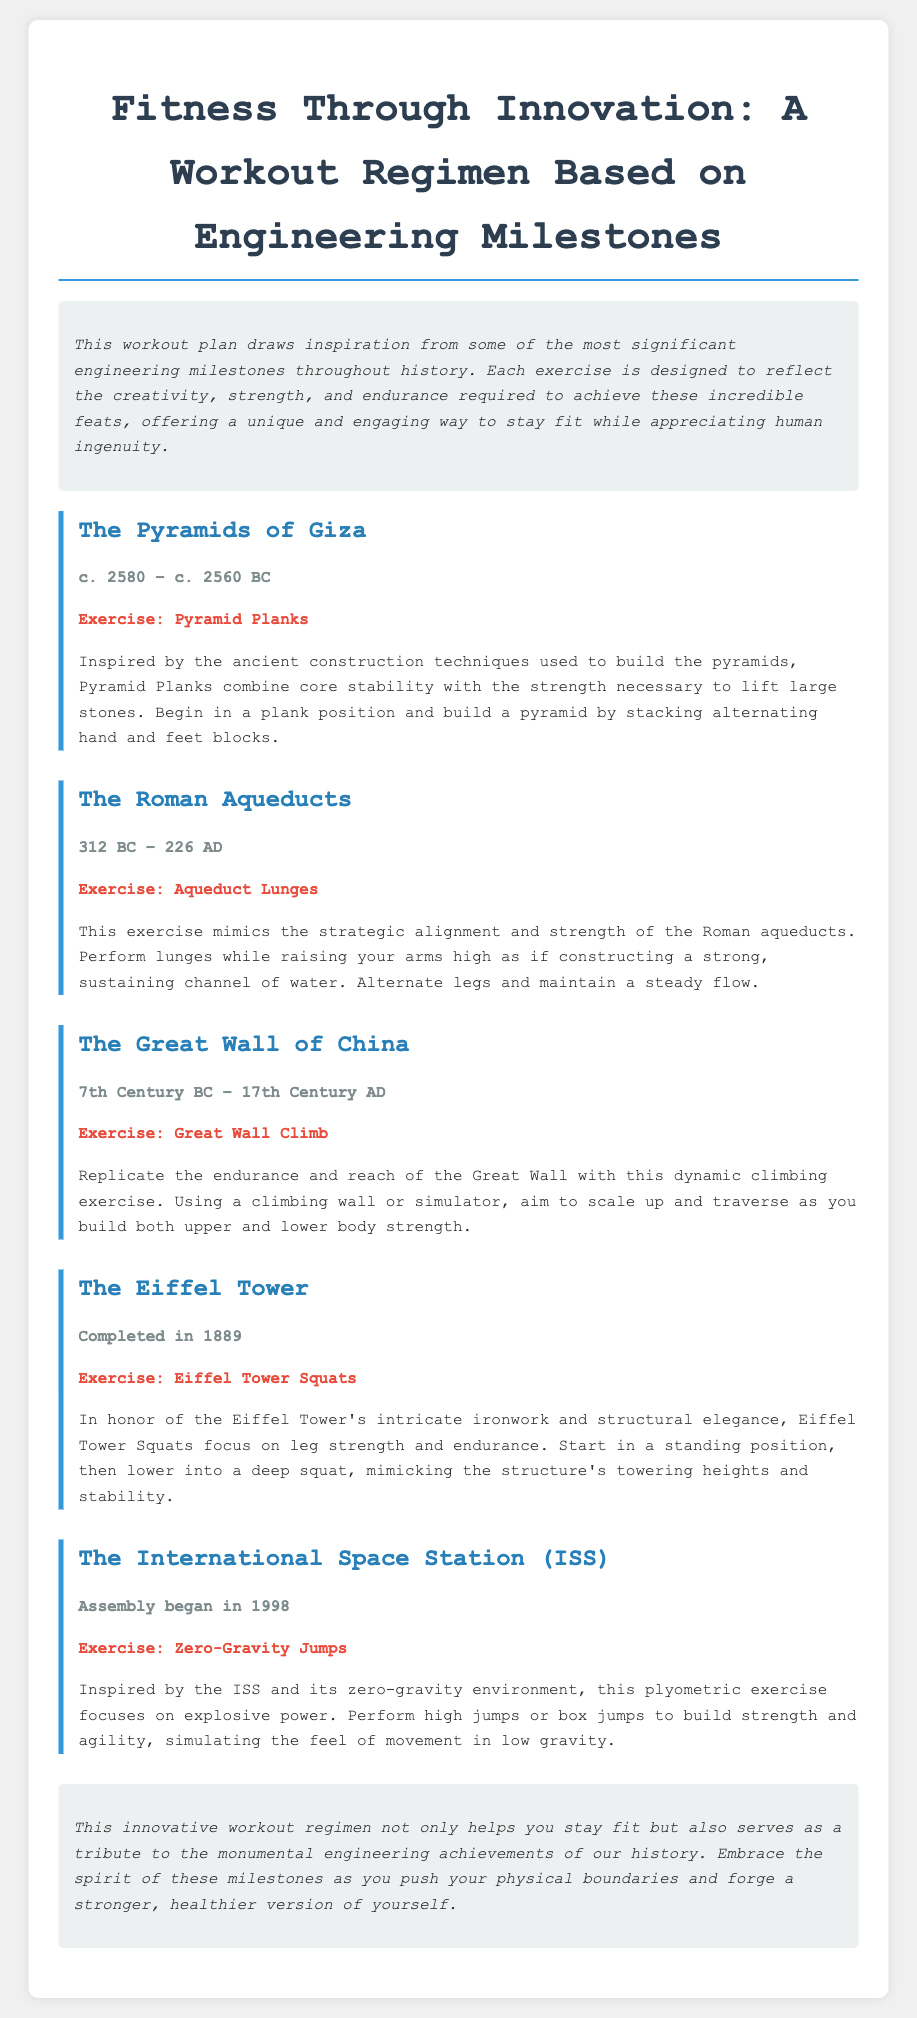What is the title of the workout plan? The title is the main heading at the top of the document, summarizing the workout regimen's theme.
Answer: Fitness Through Innovation: A Workout Regimen Based on Engineering Milestones What engineering achievement is the first exercise inspired by? The first exercise is inspired by one of the most notable ancient structures in history, specifically referenced in the document.
Answer: The Pyramids of Giza What exercise is associated with the Great Wall of China? The exercise mentions a specific workout that mimics the characteristics of this historic engineering feat, as stated in the document.
Answer: Great Wall Climb In what year was the Eiffel Tower completed? The document provides a specific date for this significant engineering milestone.
Answer: 1889 What type of exercise is performed for the International Space Station? This indicates the focus of the exercise inspired by an important modern engineering milestone detailed in the document.
Answer: Zero-Gravity Jumps How many engineering milestones are highlighted in the workout plan? The number of milestones directly stated in the document can be counted from the sections present.
Answer: Five What is the main benefit of this innovative workout regimen? The conclusion summarizes the overall impact that the workout aims to achieve for individuals participating.
Answer: Stay fit What do Pyramid Planks aim to enhance? The exercise description focuses on key physical aspects that are targeted by this particular workout.
Answer: Core stability 